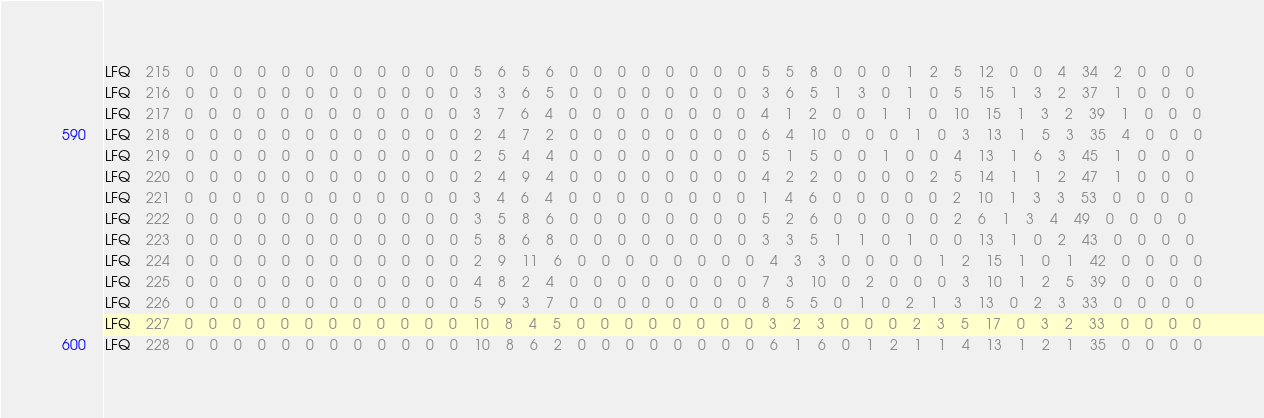<code> <loc_0><loc_0><loc_500><loc_500><_SQL_>LFQ	215	0	0	0	0	0	0	0	0	0	0	0	0	5	6	5	6	0	0	0	0	0	0	0	0	5	5	8	0	0	0	1	2	5	12	0	0	4	34	2	0	0	0
LFQ	216	0	0	0	0	0	0	0	0	0	0	0	0	3	3	6	5	0	0	0	0	0	0	0	0	3	6	5	1	3	0	1	0	5	15	1	3	2	37	1	0	0	0
LFQ	217	0	0	0	0	0	0	0	0	0	0	0	0	3	7	6	4	0	0	0	0	0	0	0	0	4	1	2	0	0	1	1	0	10	15	1	3	2	39	1	0	0	0
LFQ	218	0	0	0	0	0	0	0	0	0	0	0	0	2	4	7	2	0	0	0	0	0	0	0	0	6	4	10	0	0	0	1	0	3	13	1	5	3	35	4	0	0	0
LFQ	219	0	0	0	0	0	0	0	0	0	0	0	0	2	5	4	4	0	0	0	0	0	0	0	0	5	1	5	0	0	1	0	0	4	13	1	6	3	45	1	0	0	0
LFQ	220	0	0	0	0	0	0	0	0	0	0	0	0	2	4	9	4	0	0	0	0	0	0	0	0	4	2	2	0	0	0	0	2	5	14	1	1	2	47	1	0	0	0
LFQ	221	0	0	0	0	0	0	0	0	0	0	0	0	3	4	6	4	0	0	0	0	0	0	0	0	1	4	6	0	0	0	0	0	2	10	1	3	3	53	0	0	0	0
LFQ	222	0	0	0	0	0	0	0	0	0	0	0	0	3	5	8	6	0	0	0	0	0	0	0	0	5	2	6	0	0	0	0	0	2	6	1	3	4	49	0	0	0	0
LFQ	223	0	0	0	0	0	0	0	0	0	0	0	0	5	8	6	8	0	0	0	0	0	0	0	0	3	3	5	1	1	0	1	0	0	13	1	0	2	43	0	0	0	0
LFQ	224	0	0	0	0	0	0	0	0	0	0	0	0	2	9	11	6	0	0	0	0	0	0	0	0	4	3	3	0	0	0	0	1	2	15	1	0	1	42	0	0	0	0
LFQ	225	0	0	0	0	0	0	0	0	0	0	0	0	4	8	2	4	0	0	0	0	0	0	0	0	7	3	10	0	2	0	0	0	3	10	1	2	5	39	0	0	0	0
LFQ	226	0	0	0	0	0	0	0	0	0	0	0	0	5	9	3	7	0	0	0	0	0	0	0	0	8	5	5	0	1	0	2	1	3	13	0	2	3	33	0	0	0	0
LFQ	227	0	0	0	0	0	0	0	0	0	0	0	0	10	8	4	5	0	0	0	0	0	0	0	0	3	2	3	0	0	0	2	3	5	17	0	3	2	33	0	0	0	0
LFQ	228	0	0	0	0	0	0	0	0	0	0	0	0	10	8	6	2	0	0	0	0	0	0	0	0	6	1	6	0	1	2	1	1	4	13	1	2	1	35	0	0	0	0</code> 